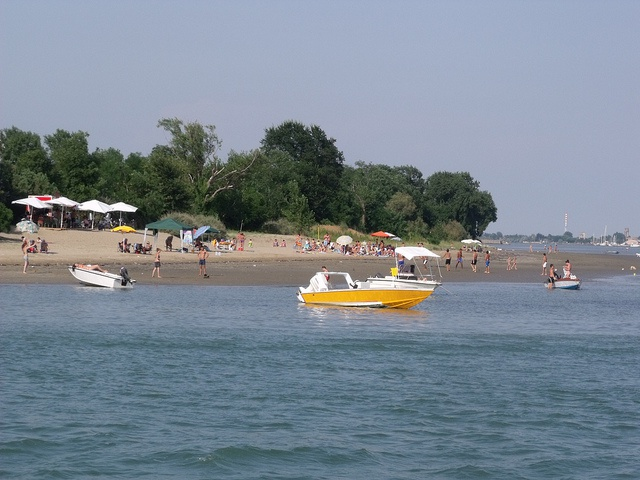Describe the objects in this image and their specific colors. I can see people in darkgray, gray, and tan tones, boat in darkgray, orange, white, and gray tones, boat in darkgray, white, gray, and black tones, umbrella in darkgray, white, gray, and black tones, and umbrella in darkgray, teal, and black tones in this image. 